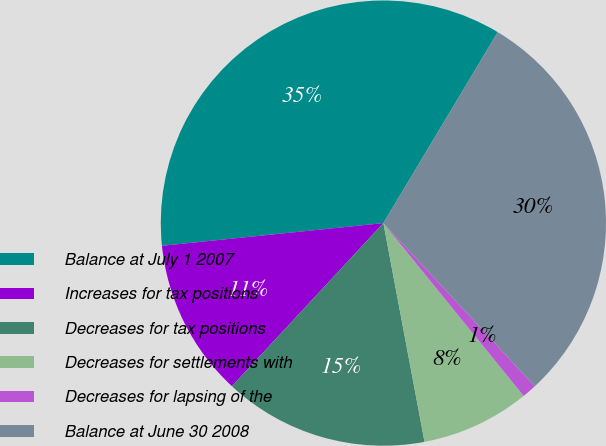Convert chart. <chart><loc_0><loc_0><loc_500><loc_500><pie_chart><fcel>Balance at July 1 2007<fcel>Increases for tax positions<fcel>Decreases for tax positions<fcel>Decreases for settlements with<fcel>Decreases for lapsing of the<fcel>Balance at June 30 2008<nl><fcel>35.21%<fcel>11.46%<fcel>14.87%<fcel>7.89%<fcel>1.06%<fcel>29.5%<nl></chart> 